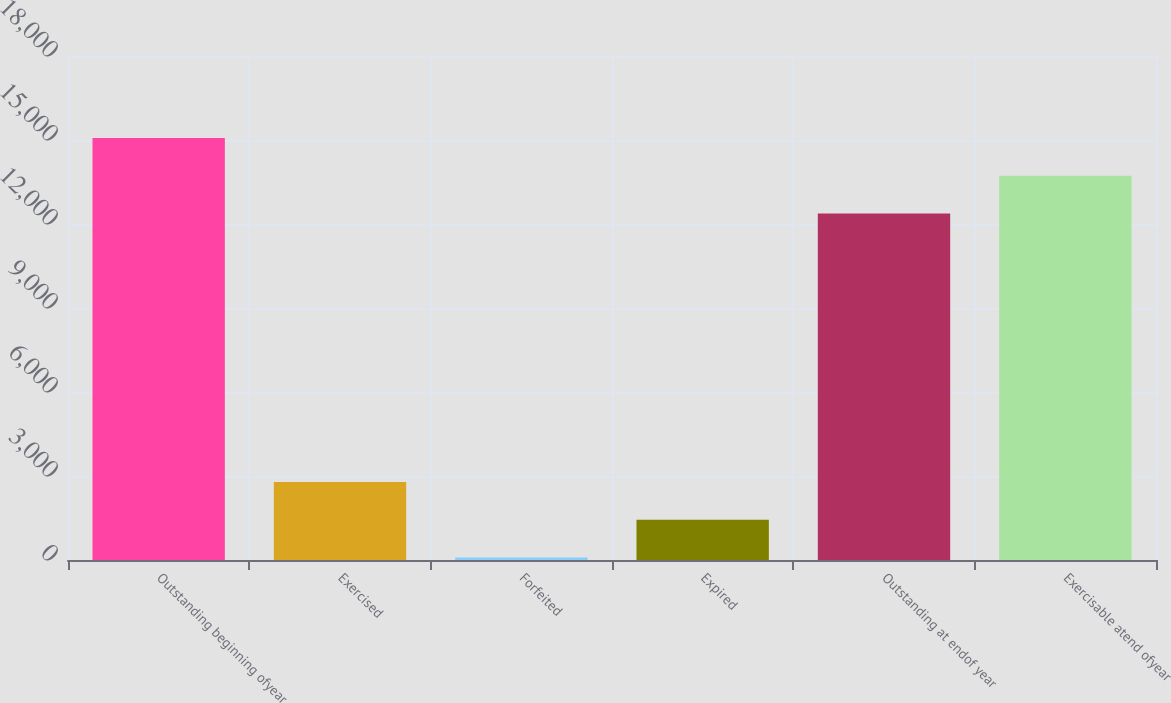<chart> <loc_0><loc_0><loc_500><loc_500><bar_chart><fcel>Outstanding beginning ofyear<fcel>Exercised<fcel>Forfeited<fcel>Expired<fcel>Outstanding at endof year<fcel>Exercisable atend ofyear<nl><fcel>15071.4<fcel>2786.4<fcel>89<fcel>1437.7<fcel>12374<fcel>13722.7<nl></chart> 